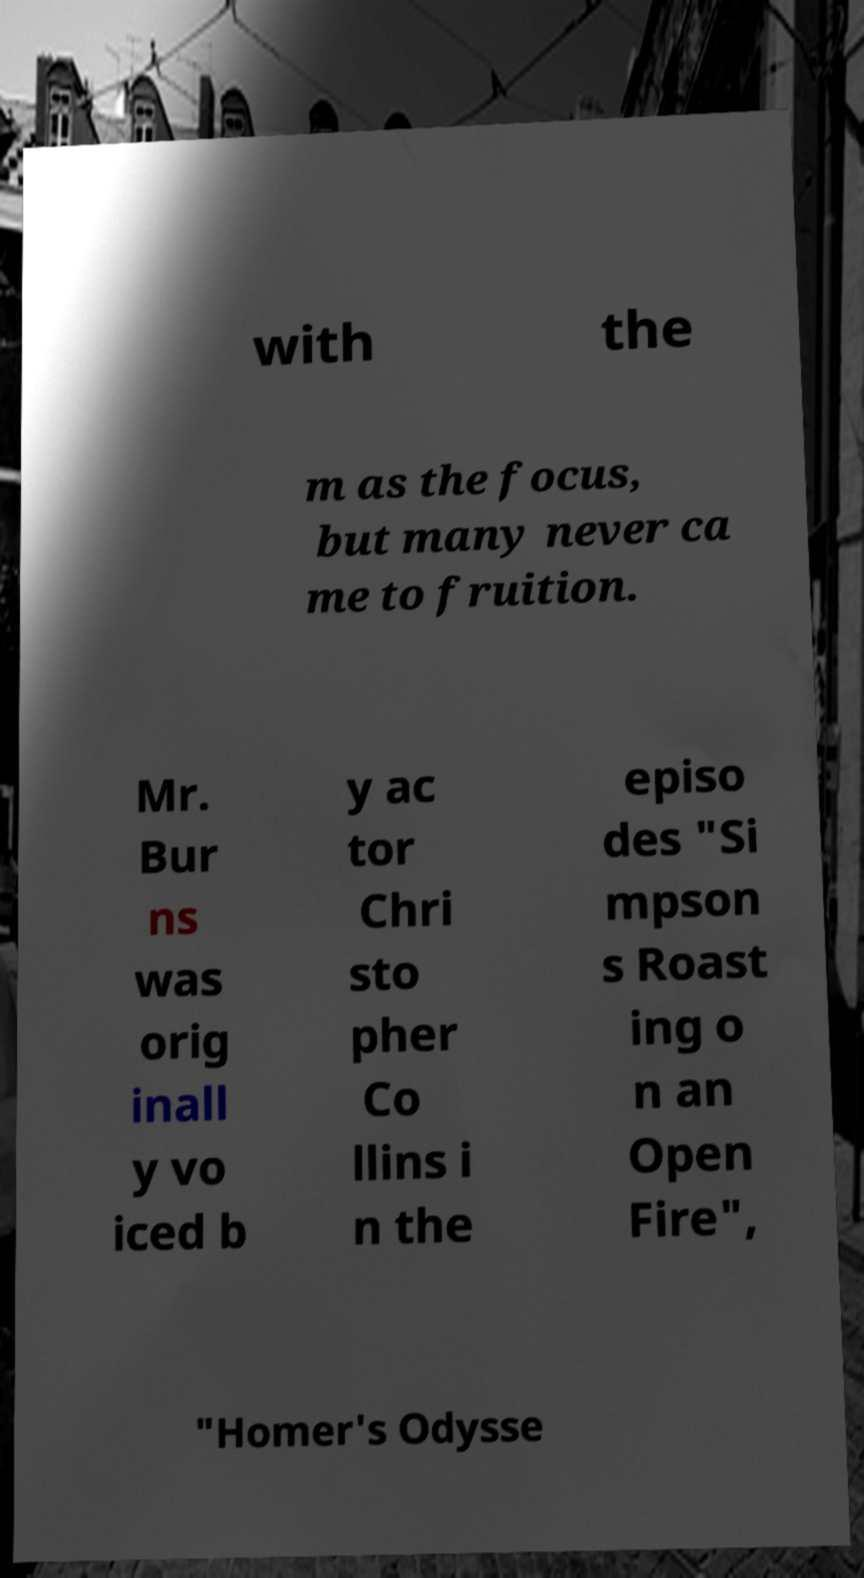For documentation purposes, I need the text within this image transcribed. Could you provide that? with the m as the focus, but many never ca me to fruition. Mr. Bur ns was orig inall y vo iced b y ac tor Chri sto pher Co llins i n the episo des "Si mpson s Roast ing o n an Open Fire", "Homer's Odysse 